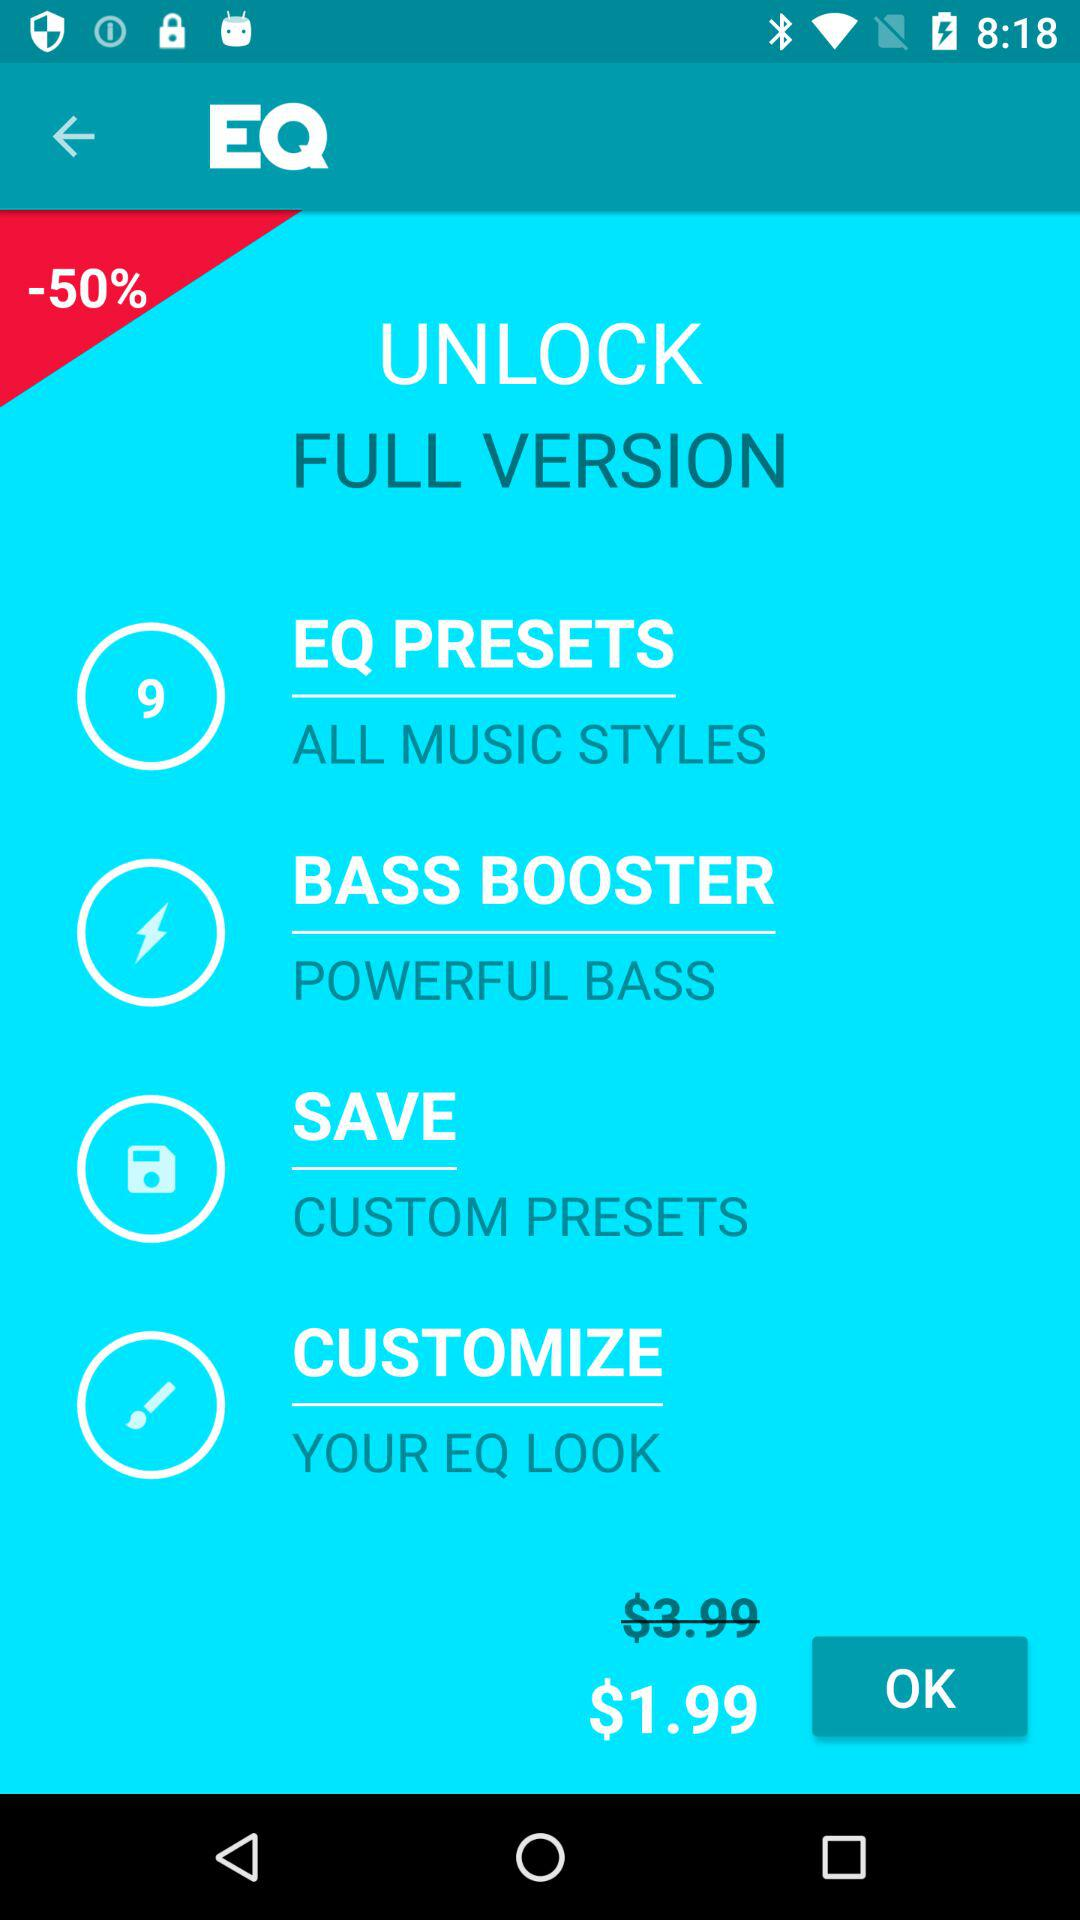What are the customization options?
When the provided information is insufficient, respond with <no answer>. <no answer> 